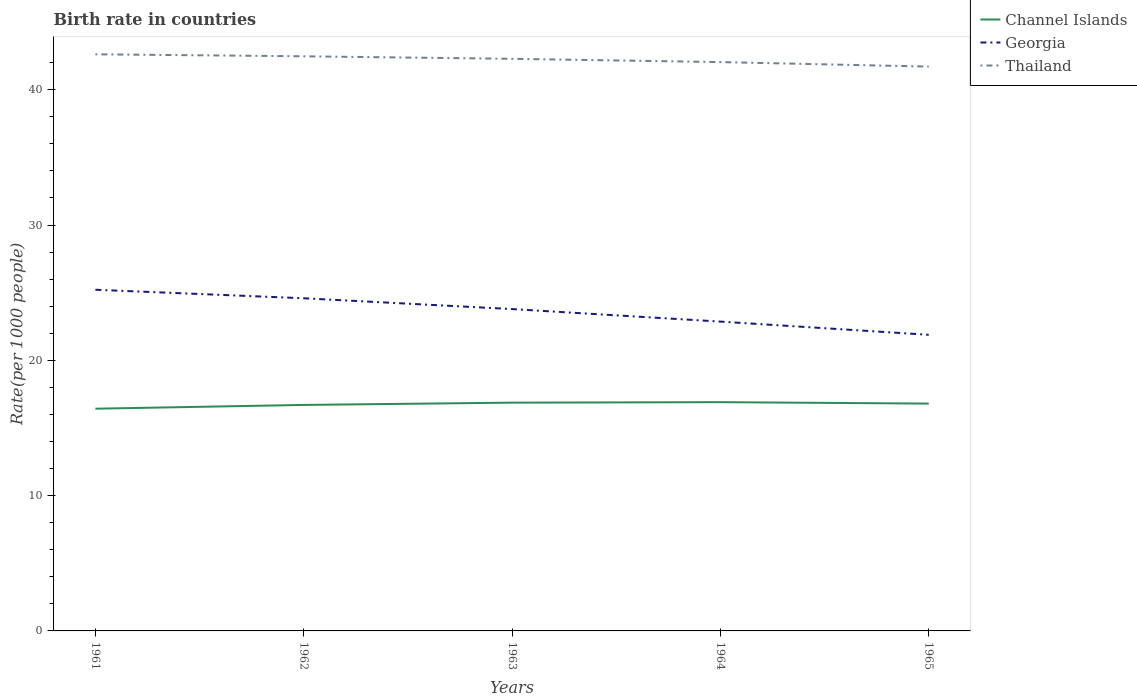How many different coloured lines are there?
Your answer should be very brief. 3. Does the line corresponding to Thailand intersect with the line corresponding to Channel Islands?
Your answer should be compact. No. Is the number of lines equal to the number of legend labels?
Keep it short and to the point. Yes. Across all years, what is the maximum birth rate in Georgia?
Provide a short and direct response. 21.89. What is the total birth rate in Georgia in the graph?
Your answer should be very brief. 1.9. What is the difference between the highest and the second highest birth rate in Thailand?
Make the answer very short. 0.91. How many years are there in the graph?
Offer a terse response. 5. What is the difference between two consecutive major ticks on the Y-axis?
Keep it short and to the point. 10. Are the values on the major ticks of Y-axis written in scientific E-notation?
Your answer should be compact. No. How many legend labels are there?
Offer a very short reply. 3. What is the title of the graph?
Offer a terse response. Birth rate in countries. Does "Kenya" appear as one of the legend labels in the graph?
Your answer should be compact. No. What is the label or title of the Y-axis?
Your response must be concise. Rate(per 1000 people). What is the Rate(per 1000 people) in Channel Islands in 1961?
Give a very brief answer. 16.42. What is the Rate(per 1000 people) of Georgia in 1961?
Your answer should be very brief. 25.22. What is the Rate(per 1000 people) of Thailand in 1961?
Your answer should be very brief. 42.62. What is the Rate(per 1000 people) of Channel Islands in 1962?
Your answer should be very brief. 16.7. What is the Rate(per 1000 people) of Georgia in 1962?
Provide a short and direct response. 24.59. What is the Rate(per 1000 people) of Thailand in 1962?
Provide a succinct answer. 42.47. What is the Rate(per 1000 people) of Channel Islands in 1963?
Ensure brevity in your answer.  16.87. What is the Rate(per 1000 people) of Georgia in 1963?
Give a very brief answer. 23.79. What is the Rate(per 1000 people) of Thailand in 1963?
Your answer should be compact. 42.28. What is the Rate(per 1000 people) of Channel Islands in 1964?
Provide a succinct answer. 16.91. What is the Rate(per 1000 people) in Georgia in 1964?
Offer a terse response. 22.86. What is the Rate(per 1000 people) of Thailand in 1964?
Provide a short and direct response. 42.04. What is the Rate(per 1000 people) of Channel Islands in 1965?
Your answer should be compact. 16.8. What is the Rate(per 1000 people) of Georgia in 1965?
Your answer should be very brief. 21.89. What is the Rate(per 1000 people) in Thailand in 1965?
Your answer should be compact. 41.71. Across all years, what is the maximum Rate(per 1000 people) in Channel Islands?
Ensure brevity in your answer.  16.91. Across all years, what is the maximum Rate(per 1000 people) in Georgia?
Offer a terse response. 25.22. Across all years, what is the maximum Rate(per 1000 people) of Thailand?
Make the answer very short. 42.62. Across all years, what is the minimum Rate(per 1000 people) in Channel Islands?
Your answer should be very brief. 16.42. Across all years, what is the minimum Rate(per 1000 people) of Georgia?
Offer a terse response. 21.89. Across all years, what is the minimum Rate(per 1000 people) of Thailand?
Provide a succinct answer. 41.71. What is the total Rate(per 1000 people) in Channel Islands in the graph?
Make the answer very short. 83.71. What is the total Rate(per 1000 people) of Georgia in the graph?
Provide a short and direct response. 118.34. What is the total Rate(per 1000 people) of Thailand in the graph?
Give a very brief answer. 211.12. What is the difference between the Rate(per 1000 people) in Channel Islands in 1961 and that in 1962?
Provide a short and direct response. -0.28. What is the difference between the Rate(per 1000 people) in Georgia in 1961 and that in 1962?
Ensure brevity in your answer.  0.63. What is the difference between the Rate(per 1000 people) of Thailand in 1961 and that in 1962?
Your answer should be compact. 0.15. What is the difference between the Rate(per 1000 people) of Channel Islands in 1961 and that in 1963?
Offer a terse response. -0.45. What is the difference between the Rate(per 1000 people) of Georgia in 1961 and that in 1963?
Provide a succinct answer. 1.43. What is the difference between the Rate(per 1000 people) in Thailand in 1961 and that in 1963?
Provide a short and direct response. 0.33. What is the difference between the Rate(per 1000 people) in Channel Islands in 1961 and that in 1964?
Keep it short and to the point. -0.48. What is the difference between the Rate(per 1000 people) in Georgia in 1961 and that in 1964?
Offer a very short reply. 2.35. What is the difference between the Rate(per 1000 people) of Thailand in 1961 and that in 1964?
Offer a terse response. 0.58. What is the difference between the Rate(per 1000 people) of Channel Islands in 1961 and that in 1965?
Your response must be concise. -0.38. What is the difference between the Rate(per 1000 people) in Georgia in 1961 and that in 1965?
Provide a short and direct response. 3.33. What is the difference between the Rate(per 1000 people) in Thailand in 1961 and that in 1965?
Your answer should be compact. 0.91. What is the difference between the Rate(per 1000 people) of Channel Islands in 1962 and that in 1963?
Make the answer very short. -0.17. What is the difference between the Rate(per 1000 people) in Georgia in 1962 and that in 1963?
Keep it short and to the point. 0.8. What is the difference between the Rate(per 1000 people) of Thailand in 1962 and that in 1963?
Your answer should be compact. 0.19. What is the difference between the Rate(per 1000 people) in Channel Islands in 1962 and that in 1964?
Your response must be concise. -0.2. What is the difference between the Rate(per 1000 people) in Georgia in 1962 and that in 1964?
Provide a succinct answer. 1.72. What is the difference between the Rate(per 1000 people) in Thailand in 1962 and that in 1964?
Your response must be concise. 0.43. What is the difference between the Rate(per 1000 people) in Channel Islands in 1962 and that in 1965?
Keep it short and to the point. -0.1. What is the difference between the Rate(per 1000 people) in Georgia in 1962 and that in 1965?
Your response must be concise. 2.7. What is the difference between the Rate(per 1000 people) of Thailand in 1962 and that in 1965?
Your answer should be compact. 0.76. What is the difference between the Rate(per 1000 people) of Channel Islands in 1963 and that in 1964?
Your response must be concise. -0.04. What is the difference between the Rate(per 1000 people) in Georgia in 1963 and that in 1964?
Your answer should be very brief. 0.93. What is the difference between the Rate(per 1000 people) in Thailand in 1963 and that in 1964?
Your answer should be compact. 0.24. What is the difference between the Rate(per 1000 people) in Channel Islands in 1963 and that in 1965?
Provide a succinct answer. 0.07. What is the difference between the Rate(per 1000 people) of Georgia in 1963 and that in 1965?
Give a very brief answer. 1.9. What is the difference between the Rate(per 1000 people) of Thailand in 1963 and that in 1965?
Your answer should be very brief. 0.57. What is the difference between the Rate(per 1000 people) in Channel Islands in 1964 and that in 1965?
Your answer should be very brief. 0.11. What is the difference between the Rate(per 1000 people) of Thailand in 1964 and that in 1965?
Provide a short and direct response. 0.33. What is the difference between the Rate(per 1000 people) in Channel Islands in 1961 and the Rate(per 1000 people) in Georgia in 1962?
Provide a succinct answer. -8.16. What is the difference between the Rate(per 1000 people) of Channel Islands in 1961 and the Rate(per 1000 people) of Thailand in 1962?
Ensure brevity in your answer.  -26.05. What is the difference between the Rate(per 1000 people) of Georgia in 1961 and the Rate(per 1000 people) of Thailand in 1962?
Give a very brief answer. -17.25. What is the difference between the Rate(per 1000 people) of Channel Islands in 1961 and the Rate(per 1000 people) of Georgia in 1963?
Make the answer very short. -7.36. What is the difference between the Rate(per 1000 people) of Channel Islands in 1961 and the Rate(per 1000 people) of Thailand in 1963?
Provide a succinct answer. -25.86. What is the difference between the Rate(per 1000 people) of Georgia in 1961 and the Rate(per 1000 people) of Thailand in 1963?
Your answer should be very brief. -17.07. What is the difference between the Rate(per 1000 people) of Channel Islands in 1961 and the Rate(per 1000 people) of Georgia in 1964?
Provide a succinct answer. -6.44. What is the difference between the Rate(per 1000 people) of Channel Islands in 1961 and the Rate(per 1000 people) of Thailand in 1964?
Offer a very short reply. -25.62. What is the difference between the Rate(per 1000 people) in Georgia in 1961 and the Rate(per 1000 people) in Thailand in 1964?
Your answer should be very brief. -16.83. What is the difference between the Rate(per 1000 people) of Channel Islands in 1961 and the Rate(per 1000 people) of Georgia in 1965?
Your answer should be very brief. -5.46. What is the difference between the Rate(per 1000 people) of Channel Islands in 1961 and the Rate(per 1000 people) of Thailand in 1965?
Offer a very short reply. -25.29. What is the difference between the Rate(per 1000 people) of Georgia in 1961 and the Rate(per 1000 people) of Thailand in 1965?
Provide a succinct answer. -16.49. What is the difference between the Rate(per 1000 people) of Channel Islands in 1962 and the Rate(per 1000 people) of Georgia in 1963?
Make the answer very short. -7.08. What is the difference between the Rate(per 1000 people) in Channel Islands in 1962 and the Rate(per 1000 people) in Thailand in 1963?
Ensure brevity in your answer.  -25.58. What is the difference between the Rate(per 1000 people) in Georgia in 1962 and the Rate(per 1000 people) in Thailand in 1963?
Ensure brevity in your answer.  -17.7. What is the difference between the Rate(per 1000 people) in Channel Islands in 1962 and the Rate(per 1000 people) in Georgia in 1964?
Provide a short and direct response. -6.16. What is the difference between the Rate(per 1000 people) in Channel Islands in 1962 and the Rate(per 1000 people) in Thailand in 1964?
Your answer should be compact. -25.34. What is the difference between the Rate(per 1000 people) of Georgia in 1962 and the Rate(per 1000 people) of Thailand in 1964?
Keep it short and to the point. -17.46. What is the difference between the Rate(per 1000 people) in Channel Islands in 1962 and the Rate(per 1000 people) in Georgia in 1965?
Make the answer very short. -5.18. What is the difference between the Rate(per 1000 people) in Channel Islands in 1962 and the Rate(per 1000 people) in Thailand in 1965?
Make the answer very short. -25.01. What is the difference between the Rate(per 1000 people) of Georgia in 1962 and the Rate(per 1000 people) of Thailand in 1965?
Your answer should be compact. -17.12. What is the difference between the Rate(per 1000 people) of Channel Islands in 1963 and the Rate(per 1000 people) of Georgia in 1964?
Keep it short and to the point. -5.99. What is the difference between the Rate(per 1000 people) of Channel Islands in 1963 and the Rate(per 1000 people) of Thailand in 1964?
Ensure brevity in your answer.  -25.17. What is the difference between the Rate(per 1000 people) in Georgia in 1963 and the Rate(per 1000 people) in Thailand in 1964?
Keep it short and to the point. -18.25. What is the difference between the Rate(per 1000 people) of Channel Islands in 1963 and the Rate(per 1000 people) of Georgia in 1965?
Keep it short and to the point. -5.01. What is the difference between the Rate(per 1000 people) in Channel Islands in 1963 and the Rate(per 1000 people) in Thailand in 1965?
Keep it short and to the point. -24.84. What is the difference between the Rate(per 1000 people) in Georgia in 1963 and the Rate(per 1000 people) in Thailand in 1965?
Keep it short and to the point. -17.92. What is the difference between the Rate(per 1000 people) in Channel Islands in 1964 and the Rate(per 1000 people) in Georgia in 1965?
Provide a short and direct response. -4.98. What is the difference between the Rate(per 1000 people) in Channel Islands in 1964 and the Rate(per 1000 people) in Thailand in 1965?
Your response must be concise. -24.8. What is the difference between the Rate(per 1000 people) of Georgia in 1964 and the Rate(per 1000 people) of Thailand in 1965?
Provide a succinct answer. -18.85. What is the average Rate(per 1000 people) of Channel Islands per year?
Give a very brief answer. 16.74. What is the average Rate(per 1000 people) of Georgia per year?
Offer a very short reply. 23.67. What is the average Rate(per 1000 people) in Thailand per year?
Offer a very short reply. 42.22. In the year 1961, what is the difference between the Rate(per 1000 people) in Channel Islands and Rate(per 1000 people) in Georgia?
Your response must be concise. -8.79. In the year 1961, what is the difference between the Rate(per 1000 people) in Channel Islands and Rate(per 1000 people) in Thailand?
Provide a short and direct response. -26.19. In the year 1961, what is the difference between the Rate(per 1000 people) of Georgia and Rate(per 1000 people) of Thailand?
Provide a short and direct response. -17.4. In the year 1962, what is the difference between the Rate(per 1000 people) in Channel Islands and Rate(per 1000 people) in Georgia?
Your answer should be compact. -7.88. In the year 1962, what is the difference between the Rate(per 1000 people) of Channel Islands and Rate(per 1000 people) of Thailand?
Offer a very short reply. -25.77. In the year 1962, what is the difference between the Rate(per 1000 people) in Georgia and Rate(per 1000 people) in Thailand?
Your answer should be very brief. -17.88. In the year 1963, what is the difference between the Rate(per 1000 people) of Channel Islands and Rate(per 1000 people) of Georgia?
Your response must be concise. -6.92. In the year 1963, what is the difference between the Rate(per 1000 people) of Channel Islands and Rate(per 1000 people) of Thailand?
Your response must be concise. -25.41. In the year 1963, what is the difference between the Rate(per 1000 people) of Georgia and Rate(per 1000 people) of Thailand?
Give a very brief answer. -18.5. In the year 1964, what is the difference between the Rate(per 1000 people) in Channel Islands and Rate(per 1000 people) in Georgia?
Keep it short and to the point. -5.95. In the year 1964, what is the difference between the Rate(per 1000 people) in Channel Islands and Rate(per 1000 people) in Thailand?
Your response must be concise. -25.13. In the year 1964, what is the difference between the Rate(per 1000 people) in Georgia and Rate(per 1000 people) in Thailand?
Keep it short and to the point. -19.18. In the year 1965, what is the difference between the Rate(per 1000 people) of Channel Islands and Rate(per 1000 people) of Georgia?
Offer a very short reply. -5.08. In the year 1965, what is the difference between the Rate(per 1000 people) of Channel Islands and Rate(per 1000 people) of Thailand?
Your answer should be compact. -24.91. In the year 1965, what is the difference between the Rate(per 1000 people) of Georgia and Rate(per 1000 people) of Thailand?
Offer a terse response. -19.82. What is the ratio of the Rate(per 1000 people) in Channel Islands in 1961 to that in 1962?
Offer a very short reply. 0.98. What is the ratio of the Rate(per 1000 people) of Georgia in 1961 to that in 1962?
Provide a succinct answer. 1.03. What is the ratio of the Rate(per 1000 people) of Channel Islands in 1961 to that in 1963?
Your answer should be compact. 0.97. What is the ratio of the Rate(per 1000 people) of Georgia in 1961 to that in 1963?
Provide a short and direct response. 1.06. What is the ratio of the Rate(per 1000 people) of Thailand in 1961 to that in 1963?
Make the answer very short. 1.01. What is the ratio of the Rate(per 1000 people) of Channel Islands in 1961 to that in 1964?
Keep it short and to the point. 0.97. What is the ratio of the Rate(per 1000 people) of Georgia in 1961 to that in 1964?
Ensure brevity in your answer.  1.1. What is the ratio of the Rate(per 1000 people) of Thailand in 1961 to that in 1964?
Offer a terse response. 1.01. What is the ratio of the Rate(per 1000 people) of Channel Islands in 1961 to that in 1965?
Make the answer very short. 0.98. What is the ratio of the Rate(per 1000 people) of Georgia in 1961 to that in 1965?
Make the answer very short. 1.15. What is the ratio of the Rate(per 1000 people) in Thailand in 1961 to that in 1965?
Provide a succinct answer. 1.02. What is the ratio of the Rate(per 1000 people) in Georgia in 1962 to that in 1963?
Offer a very short reply. 1.03. What is the ratio of the Rate(per 1000 people) of Channel Islands in 1962 to that in 1964?
Provide a succinct answer. 0.99. What is the ratio of the Rate(per 1000 people) in Georgia in 1962 to that in 1964?
Keep it short and to the point. 1.08. What is the ratio of the Rate(per 1000 people) in Thailand in 1962 to that in 1964?
Offer a terse response. 1.01. What is the ratio of the Rate(per 1000 people) of Georgia in 1962 to that in 1965?
Provide a short and direct response. 1.12. What is the ratio of the Rate(per 1000 people) in Thailand in 1962 to that in 1965?
Provide a succinct answer. 1.02. What is the ratio of the Rate(per 1000 people) in Channel Islands in 1963 to that in 1964?
Make the answer very short. 1. What is the ratio of the Rate(per 1000 people) in Georgia in 1963 to that in 1964?
Offer a terse response. 1.04. What is the ratio of the Rate(per 1000 people) of Thailand in 1963 to that in 1964?
Give a very brief answer. 1.01. What is the ratio of the Rate(per 1000 people) in Channel Islands in 1963 to that in 1965?
Ensure brevity in your answer.  1. What is the ratio of the Rate(per 1000 people) in Georgia in 1963 to that in 1965?
Provide a short and direct response. 1.09. What is the ratio of the Rate(per 1000 people) in Thailand in 1963 to that in 1965?
Your answer should be compact. 1.01. What is the ratio of the Rate(per 1000 people) in Channel Islands in 1964 to that in 1965?
Your response must be concise. 1.01. What is the ratio of the Rate(per 1000 people) of Georgia in 1964 to that in 1965?
Make the answer very short. 1.04. What is the difference between the highest and the second highest Rate(per 1000 people) of Channel Islands?
Keep it short and to the point. 0.04. What is the difference between the highest and the second highest Rate(per 1000 people) in Georgia?
Offer a terse response. 0.63. What is the difference between the highest and the second highest Rate(per 1000 people) of Thailand?
Your answer should be very brief. 0.15. What is the difference between the highest and the lowest Rate(per 1000 people) of Channel Islands?
Offer a terse response. 0.48. What is the difference between the highest and the lowest Rate(per 1000 people) in Georgia?
Keep it short and to the point. 3.33. What is the difference between the highest and the lowest Rate(per 1000 people) in Thailand?
Make the answer very short. 0.91. 